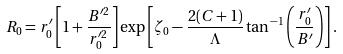<formula> <loc_0><loc_0><loc_500><loc_500>R _ { 0 } = r _ { 0 } ^ { \prime } \left [ 1 + \frac { B ^ { \prime 2 } } { r _ { 0 } ^ { \prime 2 } } \right ] \exp \left [ \zeta _ { 0 } - \frac { 2 ( C + 1 ) } { \Lambda } \tan ^ { - 1 } \left ( \frac { r _ { 0 } ^ { \prime } } { B ^ { \prime } } \right ) \right ] .</formula> 